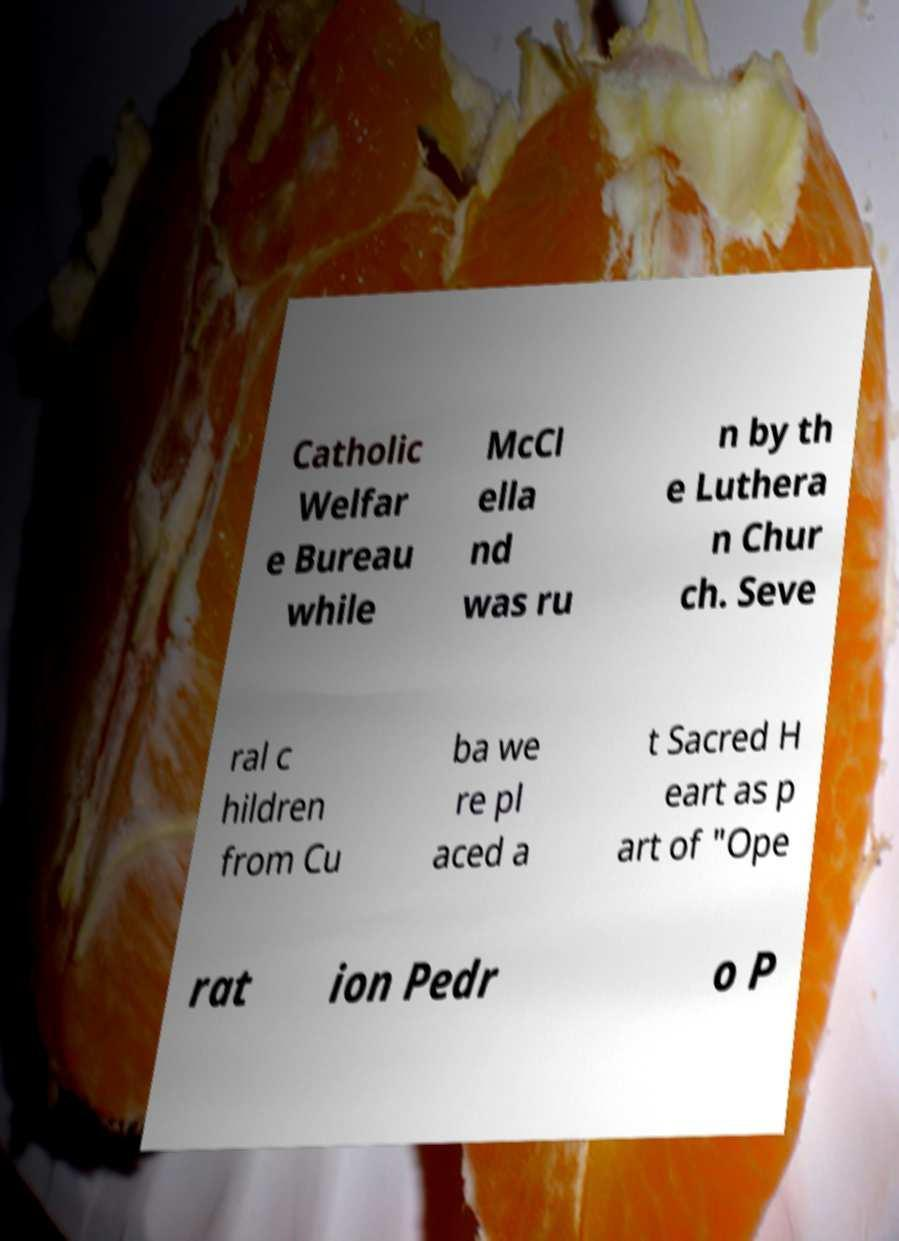Can you accurately transcribe the text from the provided image for me? Catholic Welfar e Bureau while McCl ella nd was ru n by th e Luthera n Chur ch. Seve ral c hildren from Cu ba we re pl aced a t Sacred H eart as p art of "Ope rat ion Pedr o P 